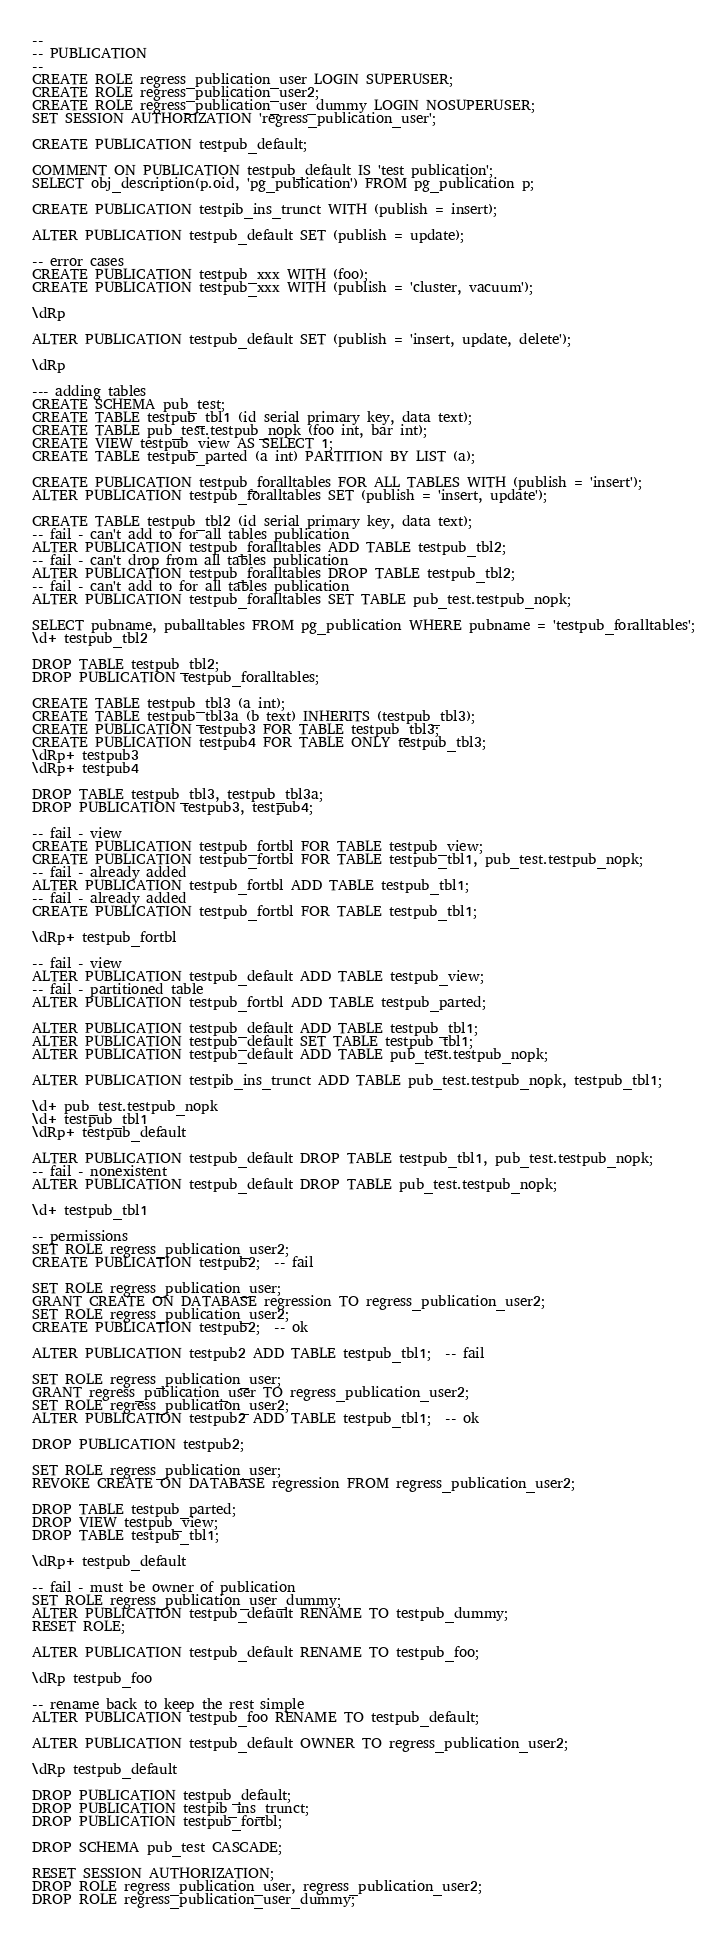<code> <loc_0><loc_0><loc_500><loc_500><_SQL_>--
-- PUBLICATION
--
CREATE ROLE regress_publication_user LOGIN SUPERUSER;
CREATE ROLE regress_publication_user2;
CREATE ROLE regress_publication_user_dummy LOGIN NOSUPERUSER;
SET SESSION AUTHORIZATION 'regress_publication_user';

CREATE PUBLICATION testpub_default;

COMMENT ON PUBLICATION testpub_default IS 'test publication';
SELECT obj_description(p.oid, 'pg_publication') FROM pg_publication p;

CREATE PUBLICATION testpib_ins_trunct WITH (publish = insert);

ALTER PUBLICATION testpub_default SET (publish = update);

-- error cases
CREATE PUBLICATION testpub_xxx WITH (foo);
CREATE PUBLICATION testpub_xxx WITH (publish = 'cluster, vacuum');

\dRp

ALTER PUBLICATION testpub_default SET (publish = 'insert, update, delete');

\dRp

--- adding tables
CREATE SCHEMA pub_test;
CREATE TABLE testpub_tbl1 (id serial primary key, data text);
CREATE TABLE pub_test.testpub_nopk (foo int, bar int);
CREATE VIEW testpub_view AS SELECT 1;
CREATE TABLE testpub_parted (a int) PARTITION BY LIST (a);

CREATE PUBLICATION testpub_foralltables FOR ALL TABLES WITH (publish = 'insert');
ALTER PUBLICATION testpub_foralltables SET (publish = 'insert, update');

CREATE TABLE testpub_tbl2 (id serial primary key, data text);
-- fail - can't add to for all tables publication
ALTER PUBLICATION testpub_foralltables ADD TABLE testpub_tbl2;
-- fail - can't drop from all tables publication
ALTER PUBLICATION testpub_foralltables DROP TABLE testpub_tbl2;
-- fail - can't add to for all tables publication
ALTER PUBLICATION testpub_foralltables SET TABLE pub_test.testpub_nopk;

SELECT pubname, puballtables FROM pg_publication WHERE pubname = 'testpub_foralltables';
\d+ testpub_tbl2

DROP TABLE testpub_tbl2;
DROP PUBLICATION testpub_foralltables;

CREATE TABLE testpub_tbl3 (a int);
CREATE TABLE testpub_tbl3a (b text) INHERITS (testpub_tbl3);
CREATE PUBLICATION testpub3 FOR TABLE testpub_tbl3;
CREATE PUBLICATION testpub4 FOR TABLE ONLY testpub_tbl3;
\dRp+ testpub3
\dRp+ testpub4

DROP TABLE testpub_tbl3, testpub_tbl3a;
DROP PUBLICATION testpub3, testpub4;

-- fail - view
CREATE PUBLICATION testpub_fortbl FOR TABLE testpub_view;
CREATE PUBLICATION testpub_fortbl FOR TABLE testpub_tbl1, pub_test.testpub_nopk;
-- fail - already added
ALTER PUBLICATION testpub_fortbl ADD TABLE testpub_tbl1;
-- fail - already added
CREATE PUBLICATION testpub_fortbl FOR TABLE testpub_tbl1;

\dRp+ testpub_fortbl

-- fail - view
ALTER PUBLICATION testpub_default ADD TABLE testpub_view;
-- fail - partitioned table
ALTER PUBLICATION testpub_fortbl ADD TABLE testpub_parted;

ALTER PUBLICATION testpub_default ADD TABLE testpub_tbl1;
ALTER PUBLICATION testpub_default SET TABLE testpub_tbl1;
ALTER PUBLICATION testpub_default ADD TABLE pub_test.testpub_nopk;

ALTER PUBLICATION testpib_ins_trunct ADD TABLE pub_test.testpub_nopk, testpub_tbl1;

\d+ pub_test.testpub_nopk
\d+ testpub_tbl1
\dRp+ testpub_default

ALTER PUBLICATION testpub_default DROP TABLE testpub_tbl1, pub_test.testpub_nopk;
-- fail - nonexistent
ALTER PUBLICATION testpub_default DROP TABLE pub_test.testpub_nopk;

\d+ testpub_tbl1

-- permissions
SET ROLE regress_publication_user2;
CREATE PUBLICATION testpub2;  -- fail

SET ROLE regress_publication_user;
GRANT CREATE ON DATABASE regression TO regress_publication_user2;
SET ROLE regress_publication_user2;
CREATE PUBLICATION testpub2;  -- ok

ALTER PUBLICATION testpub2 ADD TABLE testpub_tbl1;  -- fail

SET ROLE regress_publication_user;
GRANT regress_publication_user TO regress_publication_user2;
SET ROLE regress_publication_user2;
ALTER PUBLICATION testpub2 ADD TABLE testpub_tbl1;  -- ok

DROP PUBLICATION testpub2;

SET ROLE regress_publication_user;
REVOKE CREATE ON DATABASE regression FROM regress_publication_user2;

DROP TABLE testpub_parted;
DROP VIEW testpub_view;
DROP TABLE testpub_tbl1;

\dRp+ testpub_default

-- fail - must be owner of publication
SET ROLE regress_publication_user_dummy;
ALTER PUBLICATION testpub_default RENAME TO testpub_dummy;
RESET ROLE;

ALTER PUBLICATION testpub_default RENAME TO testpub_foo;

\dRp testpub_foo

-- rename back to keep the rest simple
ALTER PUBLICATION testpub_foo RENAME TO testpub_default;

ALTER PUBLICATION testpub_default OWNER TO regress_publication_user2;

\dRp testpub_default

DROP PUBLICATION testpub_default;
DROP PUBLICATION testpib_ins_trunct;
DROP PUBLICATION testpub_fortbl;

DROP SCHEMA pub_test CASCADE;

RESET SESSION AUTHORIZATION;
DROP ROLE regress_publication_user, regress_publication_user2;
DROP ROLE regress_publication_user_dummy;
</code> 